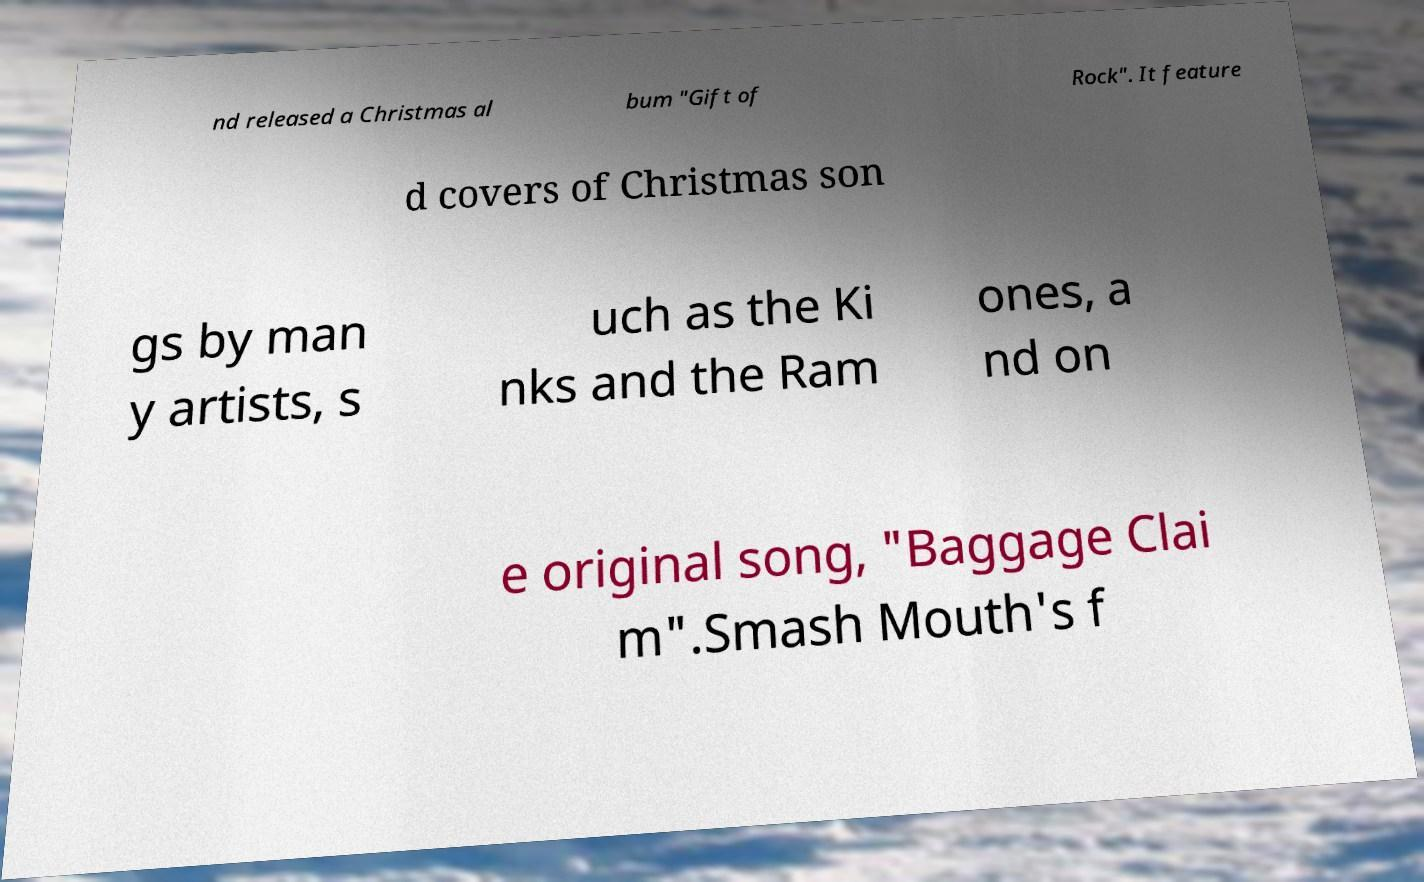Can you read and provide the text displayed in the image?This photo seems to have some interesting text. Can you extract and type it out for me? nd released a Christmas al bum "Gift of Rock". It feature d covers of Christmas son gs by man y artists, s uch as the Ki nks and the Ram ones, a nd on e original song, "Baggage Clai m".Smash Mouth's f 